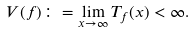<formula> <loc_0><loc_0><loc_500><loc_500>V ( f ) \colon = \lim _ { x \rightarrow \infty } T _ { f } ( x ) < \infty .</formula> 